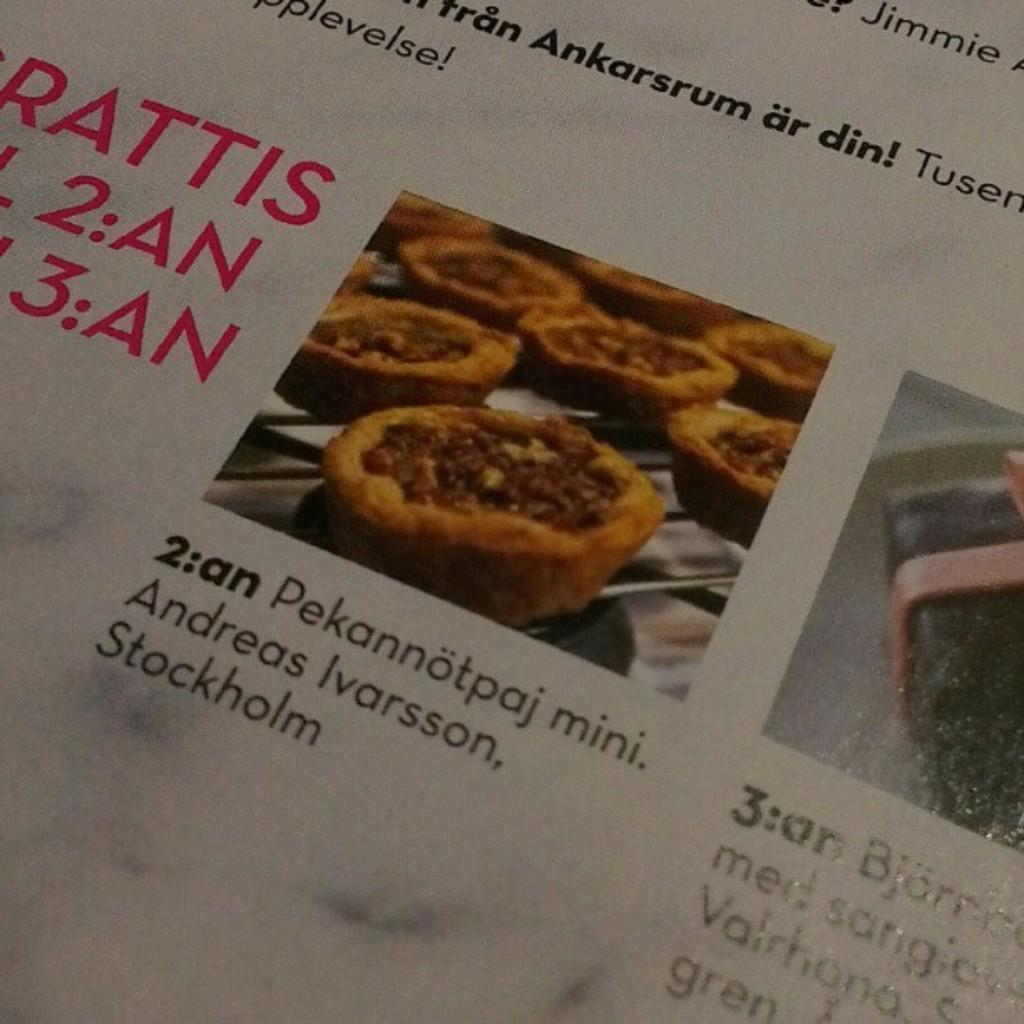What is present on the paper in the image? There is writing on the paper. What else can be seen in the image besides the paper? There are food items in the image. What is the color of the food items? The food items are in brown color. What type of milk is being poured from the bottle in the image? There is no bottle or milk present in the image. 